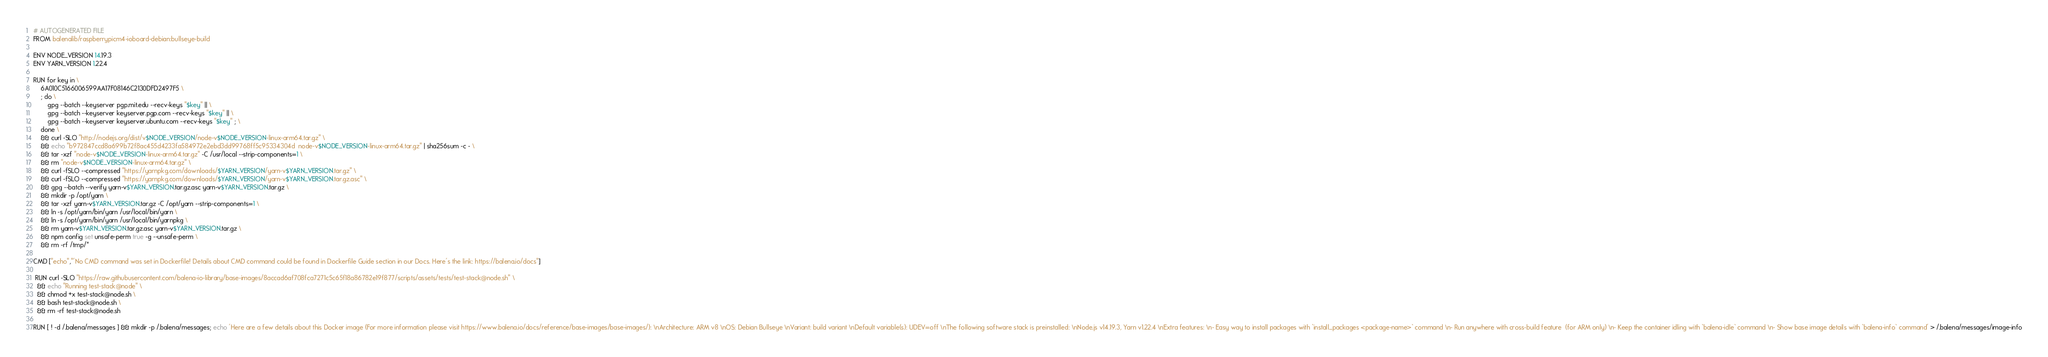<code> <loc_0><loc_0><loc_500><loc_500><_Dockerfile_># AUTOGENERATED FILE
FROM balenalib/raspberrypicm4-ioboard-debian:bullseye-build

ENV NODE_VERSION 14.19.3
ENV YARN_VERSION 1.22.4

RUN for key in \
	6A010C5166006599AA17F08146C2130DFD2497F5 \
	; do \
		gpg --batch --keyserver pgp.mit.edu --recv-keys "$key" || \
		gpg --batch --keyserver keyserver.pgp.com --recv-keys "$key" || \
		gpg --batch --keyserver keyserver.ubuntu.com --recv-keys "$key" ; \
	done \
	&& curl -SLO "http://nodejs.org/dist/v$NODE_VERSION/node-v$NODE_VERSION-linux-arm64.tar.gz" \
	&& echo "b972847ccd8a699b72f8ac455d4233fa584972e2ebd3dd99768ff5c95334304d  node-v$NODE_VERSION-linux-arm64.tar.gz" | sha256sum -c - \
	&& tar -xzf "node-v$NODE_VERSION-linux-arm64.tar.gz" -C /usr/local --strip-components=1 \
	&& rm "node-v$NODE_VERSION-linux-arm64.tar.gz" \
	&& curl -fSLO --compressed "https://yarnpkg.com/downloads/$YARN_VERSION/yarn-v$YARN_VERSION.tar.gz" \
	&& curl -fSLO --compressed "https://yarnpkg.com/downloads/$YARN_VERSION/yarn-v$YARN_VERSION.tar.gz.asc" \
	&& gpg --batch --verify yarn-v$YARN_VERSION.tar.gz.asc yarn-v$YARN_VERSION.tar.gz \
	&& mkdir -p /opt/yarn \
	&& tar -xzf yarn-v$YARN_VERSION.tar.gz -C /opt/yarn --strip-components=1 \
	&& ln -s /opt/yarn/bin/yarn /usr/local/bin/yarn \
	&& ln -s /opt/yarn/bin/yarn /usr/local/bin/yarnpkg \
	&& rm yarn-v$YARN_VERSION.tar.gz.asc yarn-v$YARN_VERSION.tar.gz \
	&& npm config set unsafe-perm true -g --unsafe-perm \
	&& rm -rf /tmp/*

CMD ["echo","'No CMD command was set in Dockerfile! Details about CMD command could be found in Dockerfile Guide section in our Docs. Here's the link: https://balena.io/docs"]

 RUN curl -SLO "https://raw.githubusercontent.com/balena-io-library/base-images/8accad6af708fca7271c5c65f18a86782e19f877/scripts/assets/tests/test-stack@node.sh" \
  && echo "Running test-stack@node" \
  && chmod +x test-stack@node.sh \
  && bash test-stack@node.sh \
  && rm -rf test-stack@node.sh 

RUN [ ! -d /.balena/messages ] && mkdir -p /.balena/messages; echo 'Here are a few details about this Docker image (For more information please visit https://www.balena.io/docs/reference/base-images/base-images/): \nArchitecture: ARM v8 \nOS: Debian Bullseye \nVariant: build variant \nDefault variable(s): UDEV=off \nThe following software stack is preinstalled: \nNode.js v14.19.3, Yarn v1.22.4 \nExtra features: \n- Easy way to install packages with `install_packages <package-name>` command \n- Run anywhere with cross-build feature  (for ARM only) \n- Keep the container idling with `balena-idle` command \n- Show base image details with `balena-info` command' > /.balena/messages/image-info</code> 